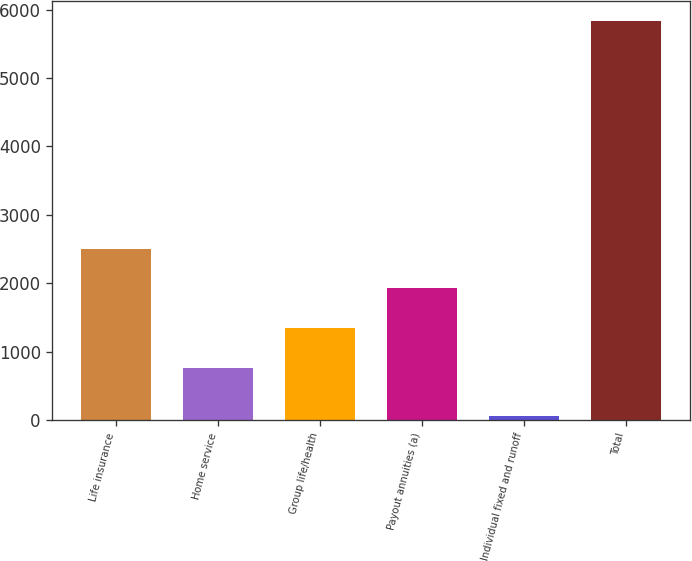Convert chart. <chart><loc_0><loc_0><loc_500><loc_500><bar_chart><fcel>Life insurance<fcel>Home service<fcel>Group life/health<fcel>Payout annuities (a)<fcel>Individual fixed and runoff<fcel>Total<nl><fcel>2501.3<fcel>767<fcel>1345.1<fcel>1923.2<fcel>55<fcel>5836<nl></chart> 